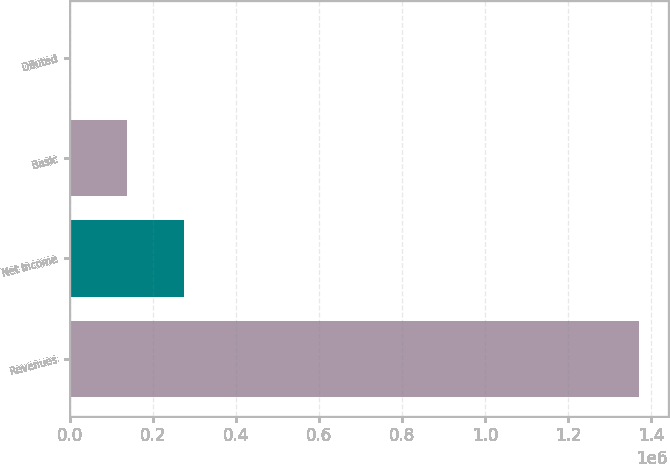Convert chart to OTSL. <chart><loc_0><loc_0><loc_500><loc_500><bar_chart><fcel>Revenues<fcel>Net income<fcel>Basic<fcel>Diluted<nl><fcel>1.37095e+06<fcel>274191<fcel>137096<fcel>0.82<nl></chart> 